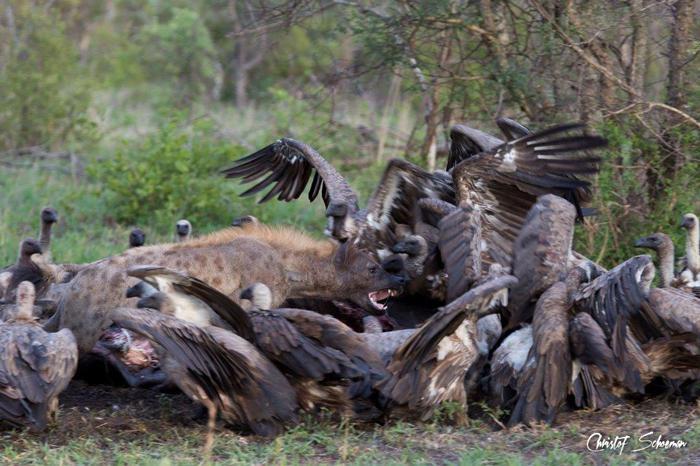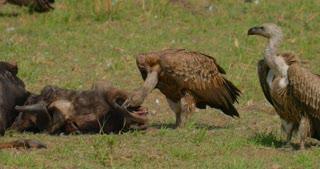The first image is the image on the left, the second image is the image on the right. Given the left and right images, does the statement "In one of the images, the animals are obviously feasting on zebra." hold true? Answer yes or no. No. 